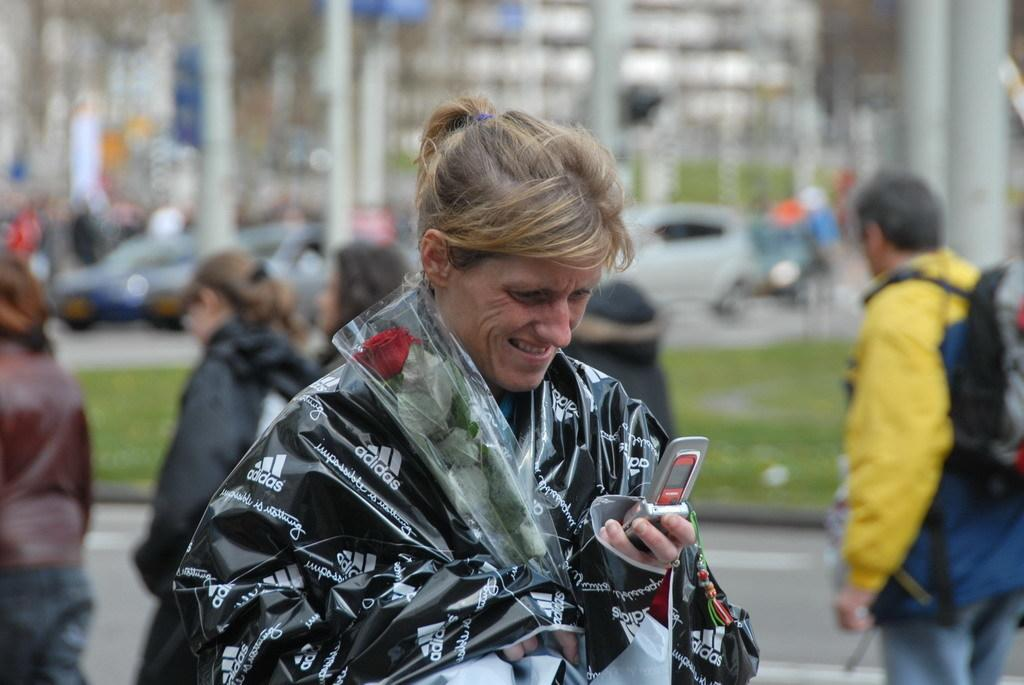What is the person in the image holding? The person is holding a mobile and a flower bouquet. Can you describe the background of the image? The background of the image includes a road, grass, vehicles, and some objects. The background is blurry. How many people are visible in the image? There is one person in the foreground and some people in the background. What type of wren can be seen sitting on the roof in the image? There is no wren or roof present in the image. What color is the sheet draped over the person in the image? There is no sheet present in the image; the person is holding a mobile and a flower bouquet. 